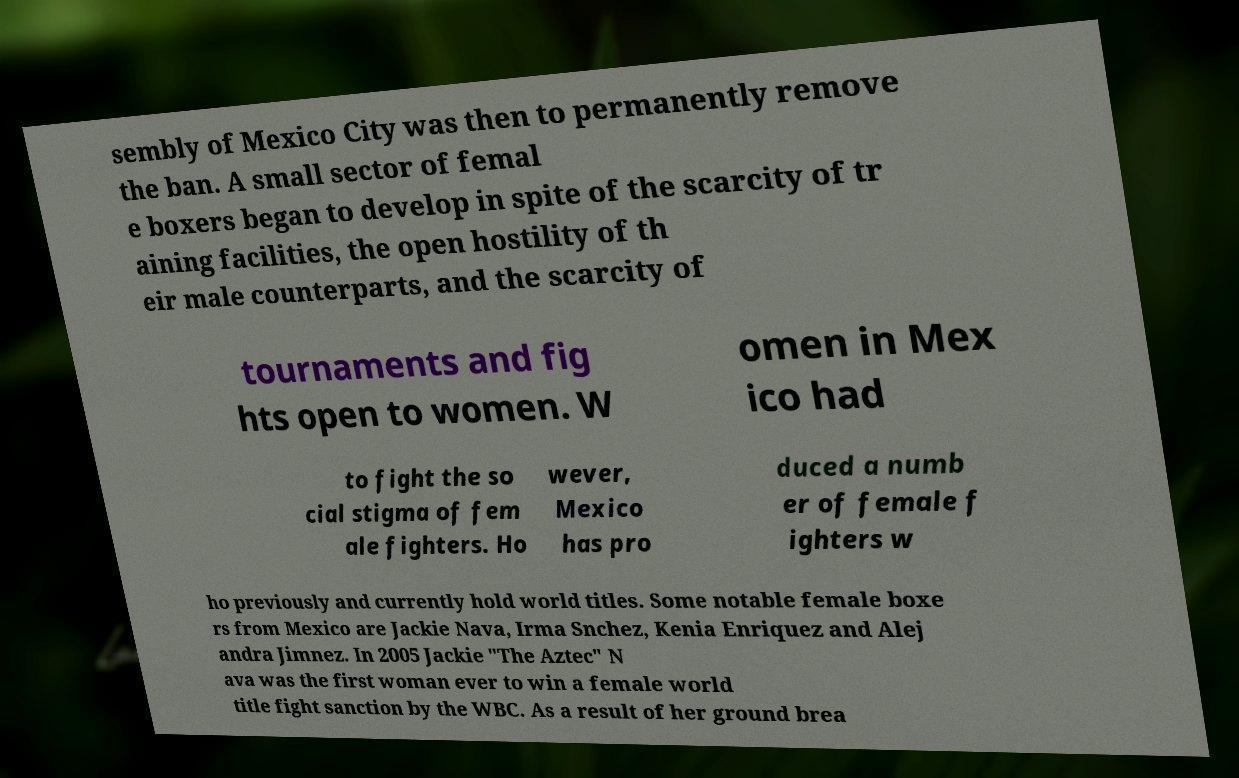Can you read and provide the text displayed in the image?This photo seems to have some interesting text. Can you extract and type it out for me? sembly of Mexico City was then to permanently remove the ban. A small sector of femal e boxers began to develop in spite of the scarcity of tr aining facilities, the open hostility of th eir male counterparts, and the scarcity of tournaments and fig hts open to women. W omen in Mex ico had to fight the so cial stigma of fem ale fighters. Ho wever, Mexico has pro duced a numb er of female f ighters w ho previously and currently hold world titles. Some notable female boxe rs from Mexico are Jackie Nava, Irma Snchez, Kenia Enriquez and Alej andra Jimnez. In 2005 Jackie "The Aztec" N ava was the first woman ever to win a female world title fight sanction by the WBC. As a result of her ground brea 